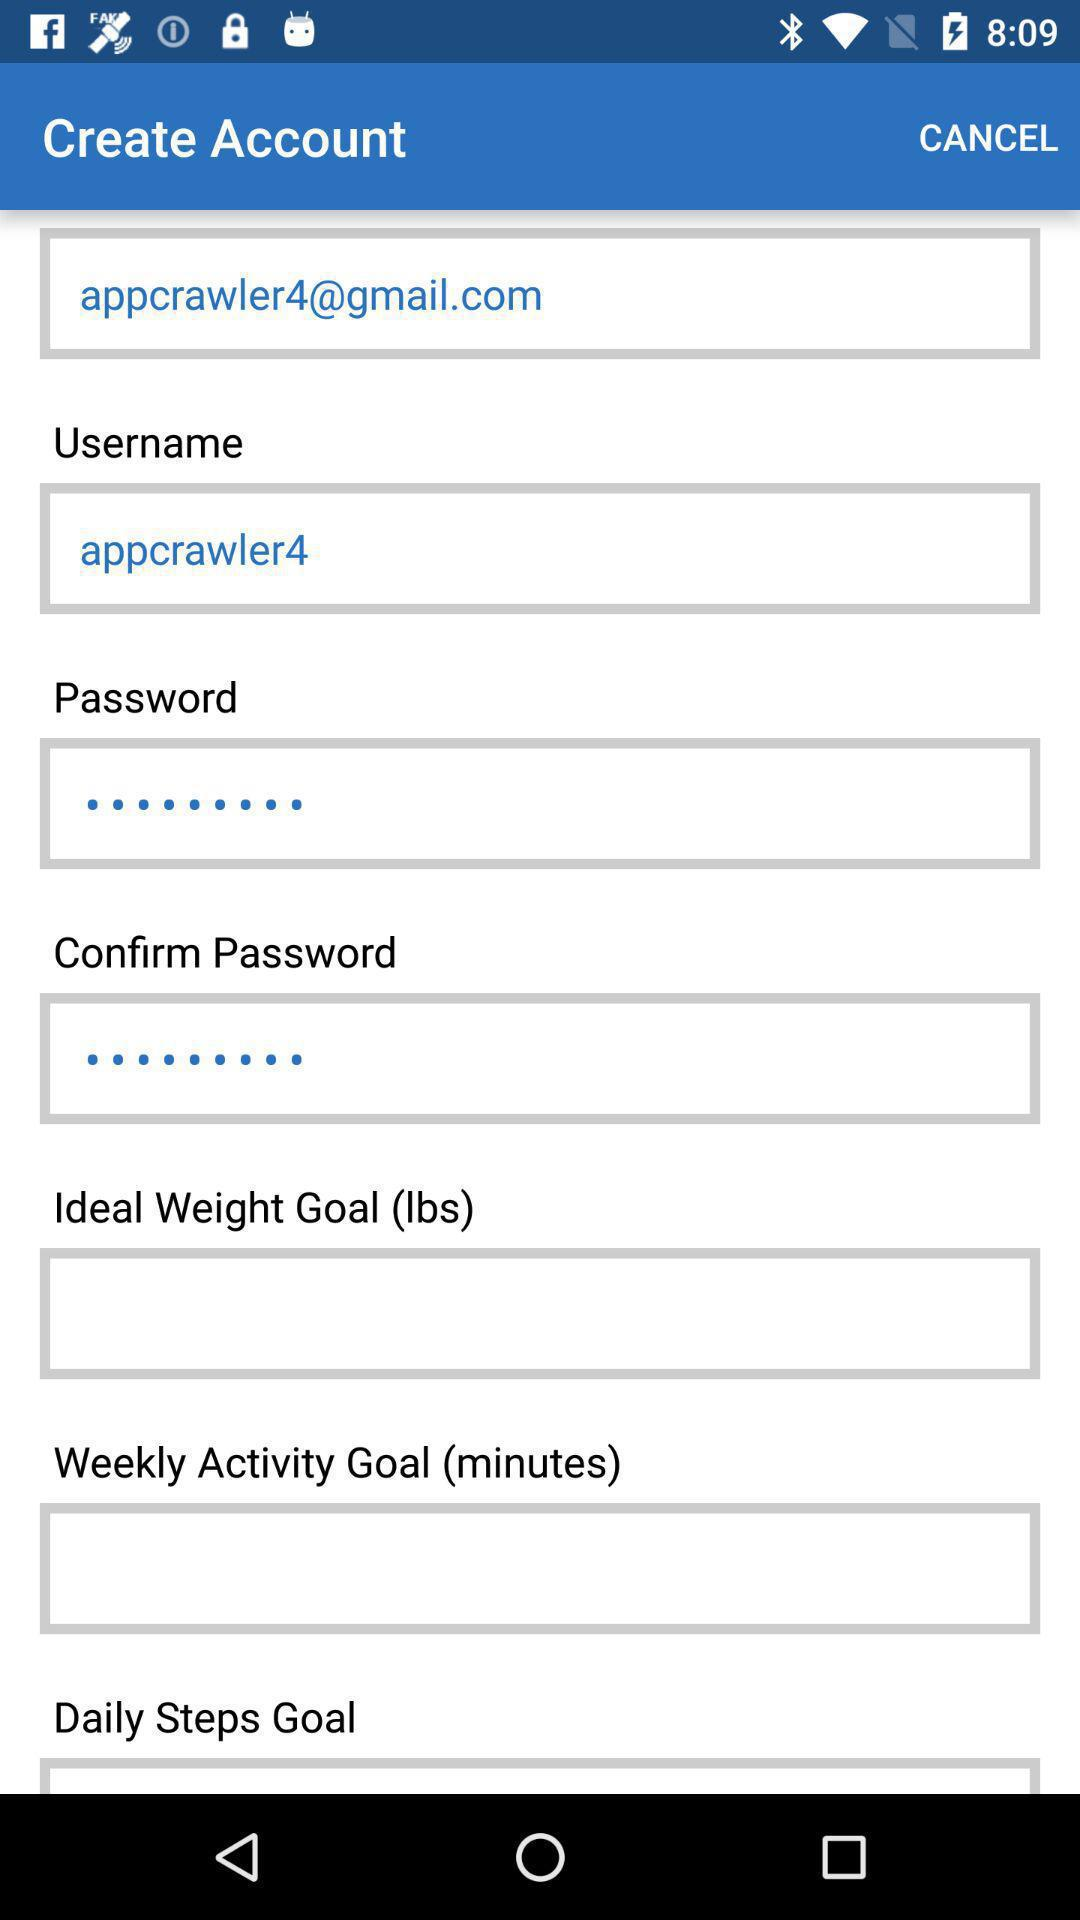What is the username? The username is "appcrawler4". 